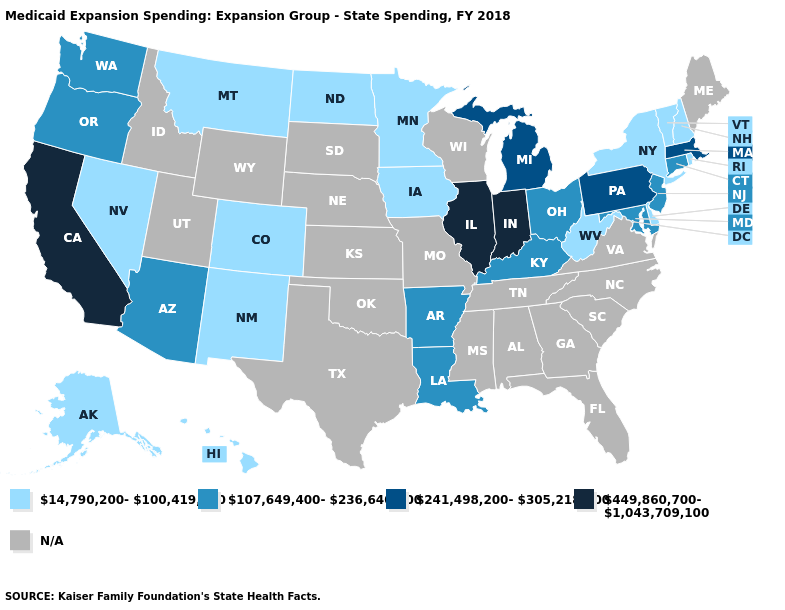Is the legend a continuous bar?
Quick response, please. No. Among the states that border Wisconsin , does Minnesota have the highest value?
Answer briefly. No. What is the value of Florida?
Quick response, please. N/A. Is the legend a continuous bar?
Answer briefly. No. Name the states that have a value in the range 14,790,200-100,419,200?
Short answer required. Alaska, Colorado, Delaware, Hawaii, Iowa, Minnesota, Montana, Nevada, New Hampshire, New Mexico, New York, North Dakota, Rhode Island, Vermont, West Virginia. What is the value of Tennessee?
Give a very brief answer. N/A. What is the value of Michigan?
Short answer required. 241,498,200-305,218,900. What is the lowest value in the USA?
Write a very short answer. 14,790,200-100,419,200. Name the states that have a value in the range 14,790,200-100,419,200?
Be succinct. Alaska, Colorado, Delaware, Hawaii, Iowa, Minnesota, Montana, Nevada, New Hampshire, New Mexico, New York, North Dakota, Rhode Island, Vermont, West Virginia. Name the states that have a value in the range N/A?
Concise answer only. Alabama, Florida, Georgia, Idaho, Kansas, Maine, Mississippi, Missouri, Nebraska, North Carolina, Oklahoma, South Carolina, South Dakota, Tennessee, Texas, Utah, Virginia, Wisconsin, Wyoming. Name the states that have a value in the range 14,790,200-100,419,200?
Write a very short answer. Alaska, Colorado, Delaware, Hawaii, Iowa, Minnesota, Montana, Nevada, New Hampshire, New Mexico, New York, North Dakota, Rhode Island, Vermont, West Virginia. Name the states that have a value in the range N/A?
Short answer required. Alabama, Florida, Georgia, Idaho, Kansas, Maine, Mississippi, Missouri, Nebraska, North Carolina, Oklahoma, South Carolina, South Dakota, Tennessee, Texas, Utah, Virginia, Wisconsin, Wyoming. Name the states that have a value in the range 241,498,200-305,218,900?
Write a very short answer. Massachusetts, Michigan, Pennsylvania. Among the states that border Wyoming , which have the highest value?
Quick response, please. Colorado, Montana. 